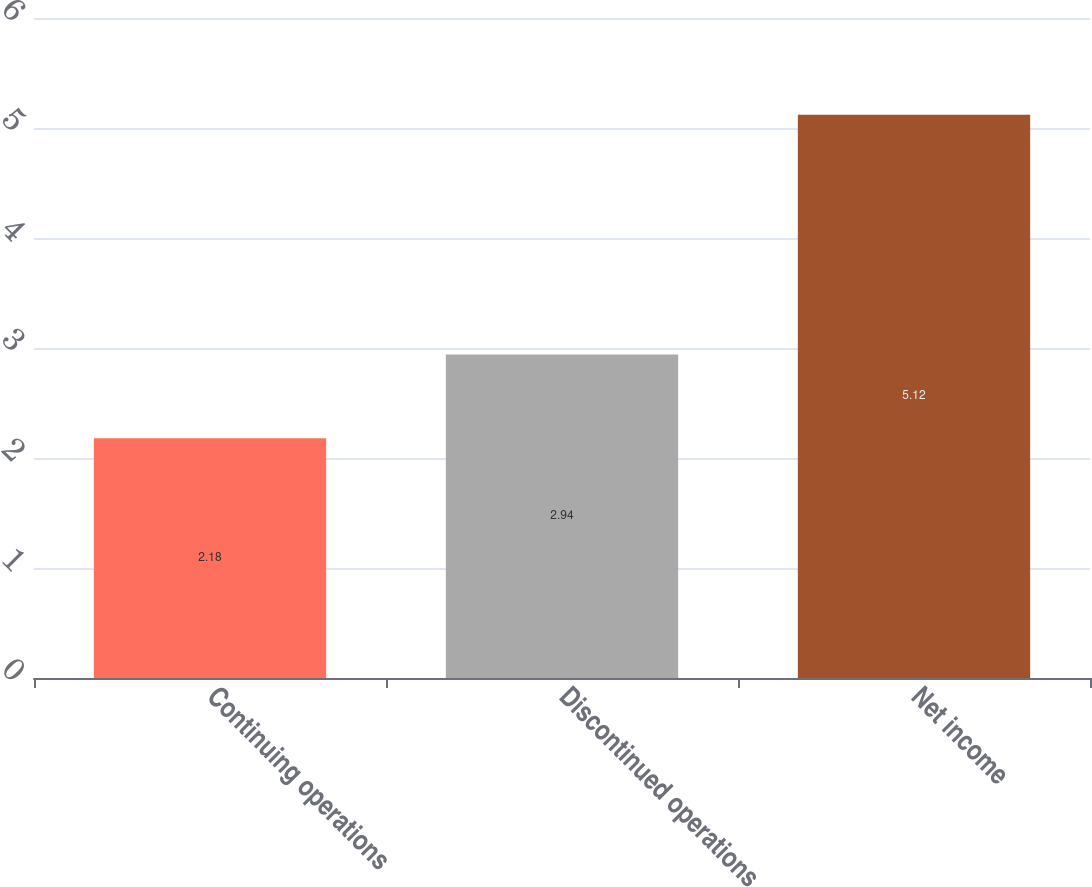Convert chart to OTSL. <chart><loc_0><loc_0><loc_500><loc_500><bar_chart><fcel>Continuing operations<fcel>Discontinued operations<fcel>Net income<nl><fcel>2.18<fcel>2.94<fcel>5.12<nl></chart> 